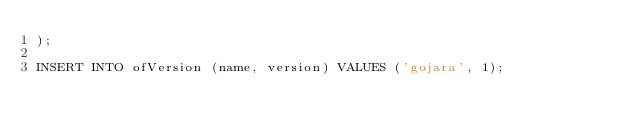<code> <loc_0><loc_0><loc_500><loc_500><_SQL_>);

INSERT INTO ofVersion (name, version) VALUES ('gojara', 1);
</code> 